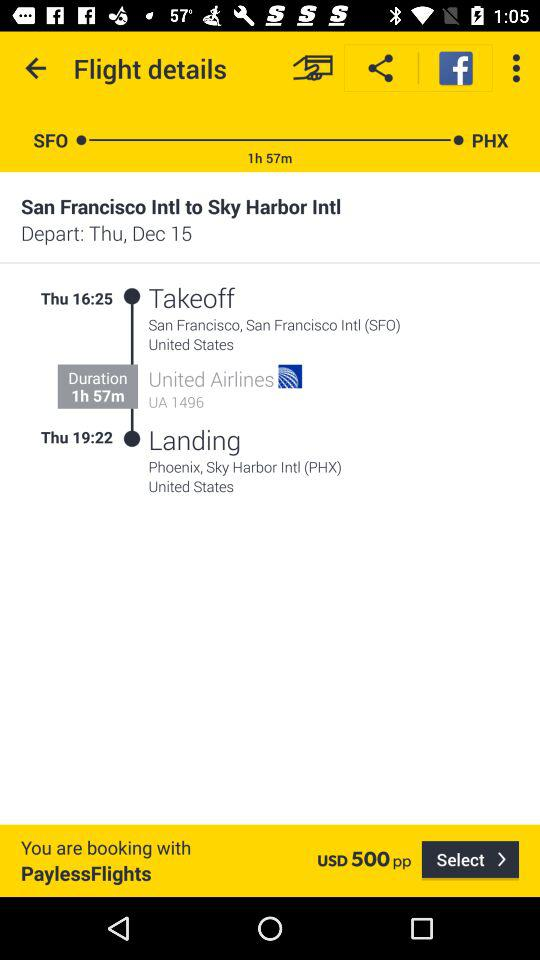What is the landing location? The landing location is Phoenix, Sky Harbor Intl. (PHX), United States. 